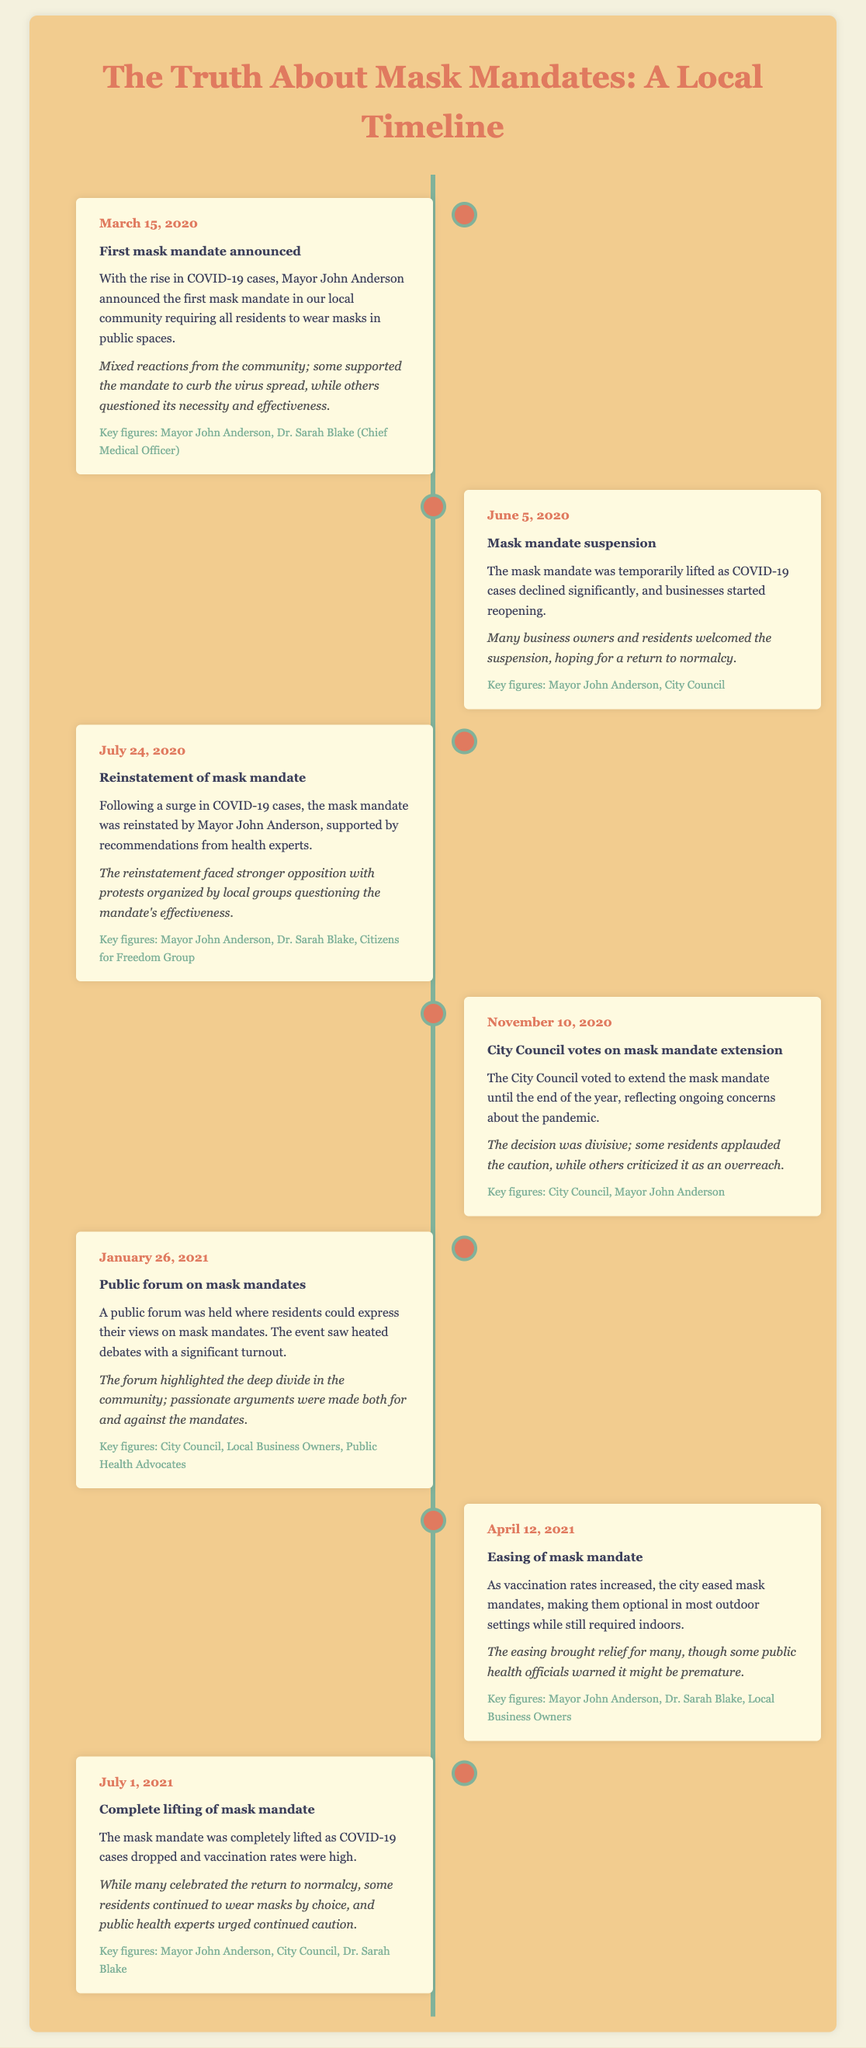What date was the first mask mandate announced? The first mask mandate was announced on March 15, 2020, according to the document timeline.
Answer: March 15, 2020 Who was the mayor during the initial mask mandate? The timeline indicates that Mayor John Anderson was in office during the first mask mandate announcement.
Answer: Mayor John Anderson What was the community's reaction to the mask mandate suspension? The document notes that many business owners and residents welcomed the suspension of the mask mandate.
Answer: Welcomed the suspension On what date was the mask mandate reinstated? The mask mandate was reinstated on July 24, 2020, as detailed in the timeline.
Answer: July 24, 2020 What key figure supported the reinstatement of the mask mandate? The timeline mentions that Dr. Sarah Blake, the Chief Medical Officer, supported the reinstatement of the mask mandate.
Answer: Dr. Sarah Blake How many key figures were involved in the public forum on mask mandates? The public forum on January 26, 2021, involved several key figures including the City Council and local business owners.
Answer: Multiple (City Council, Local Business Owners, Public Health Advocates) What was the date of the complete lifting of the mask mandate? The mask mandate was completely lifted on July 1, 2021, as per the timeline.
Answer: July 1, 2021 What kind of event was held on January 26, 2021? The event held on this date was a public forum where residents expressed their views on mask mandates.
Answer: Public forum What significant change occurred on April 12, 2021, regarding mask mandates? On this date, the city eased mask mandates, making them optional in most outdoor settings.
Answer: Eased mask mandates 